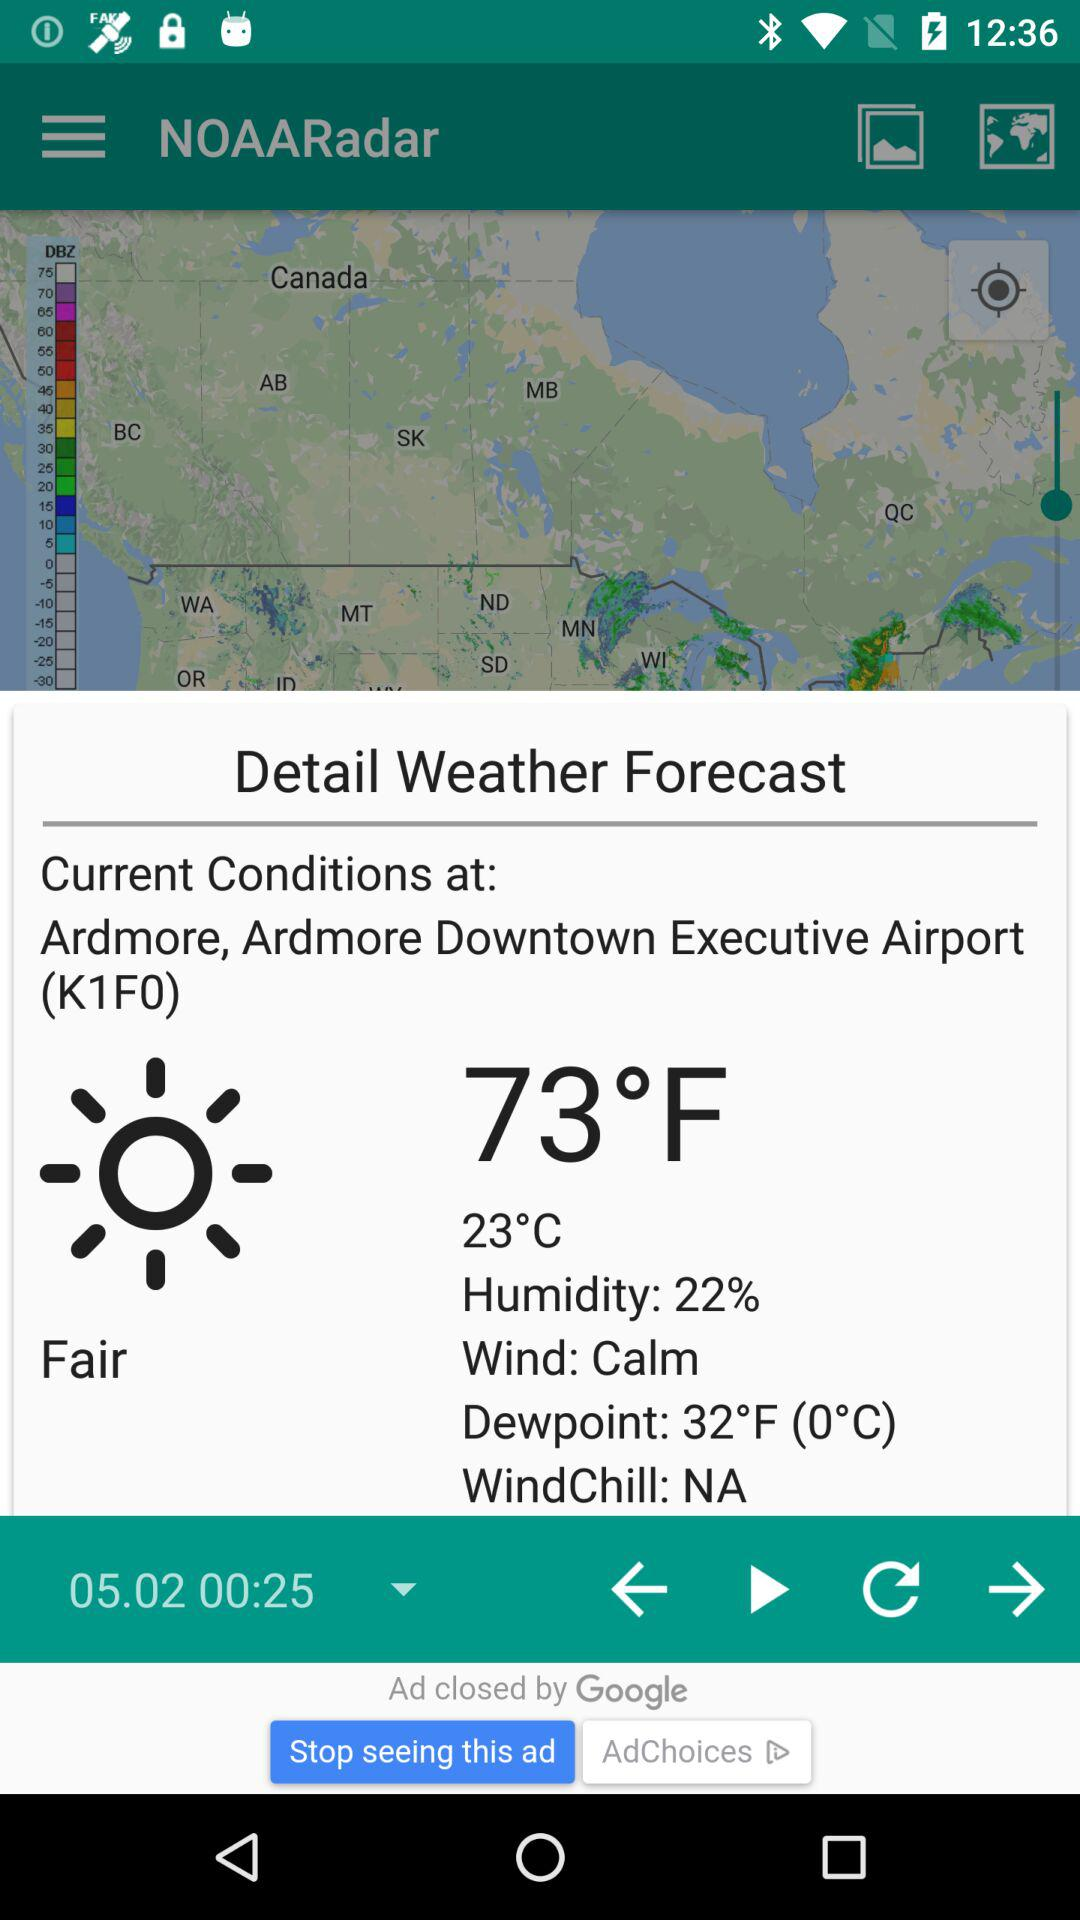What is the condition of WindChill? The condition of WindChill is NA. 